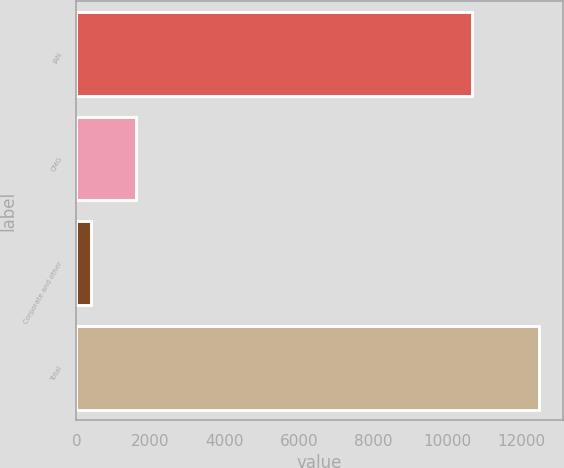<chart> <loc_0><loc_0><loc_500><loc_500><bar_chart><fcel>IAN<fcel>CMG<fcel>Corporate and other<fcel>Total<nl><fcel>10660<fcel>1605.73<fcel>396.9<fcel>12485.2<nl></chart> 